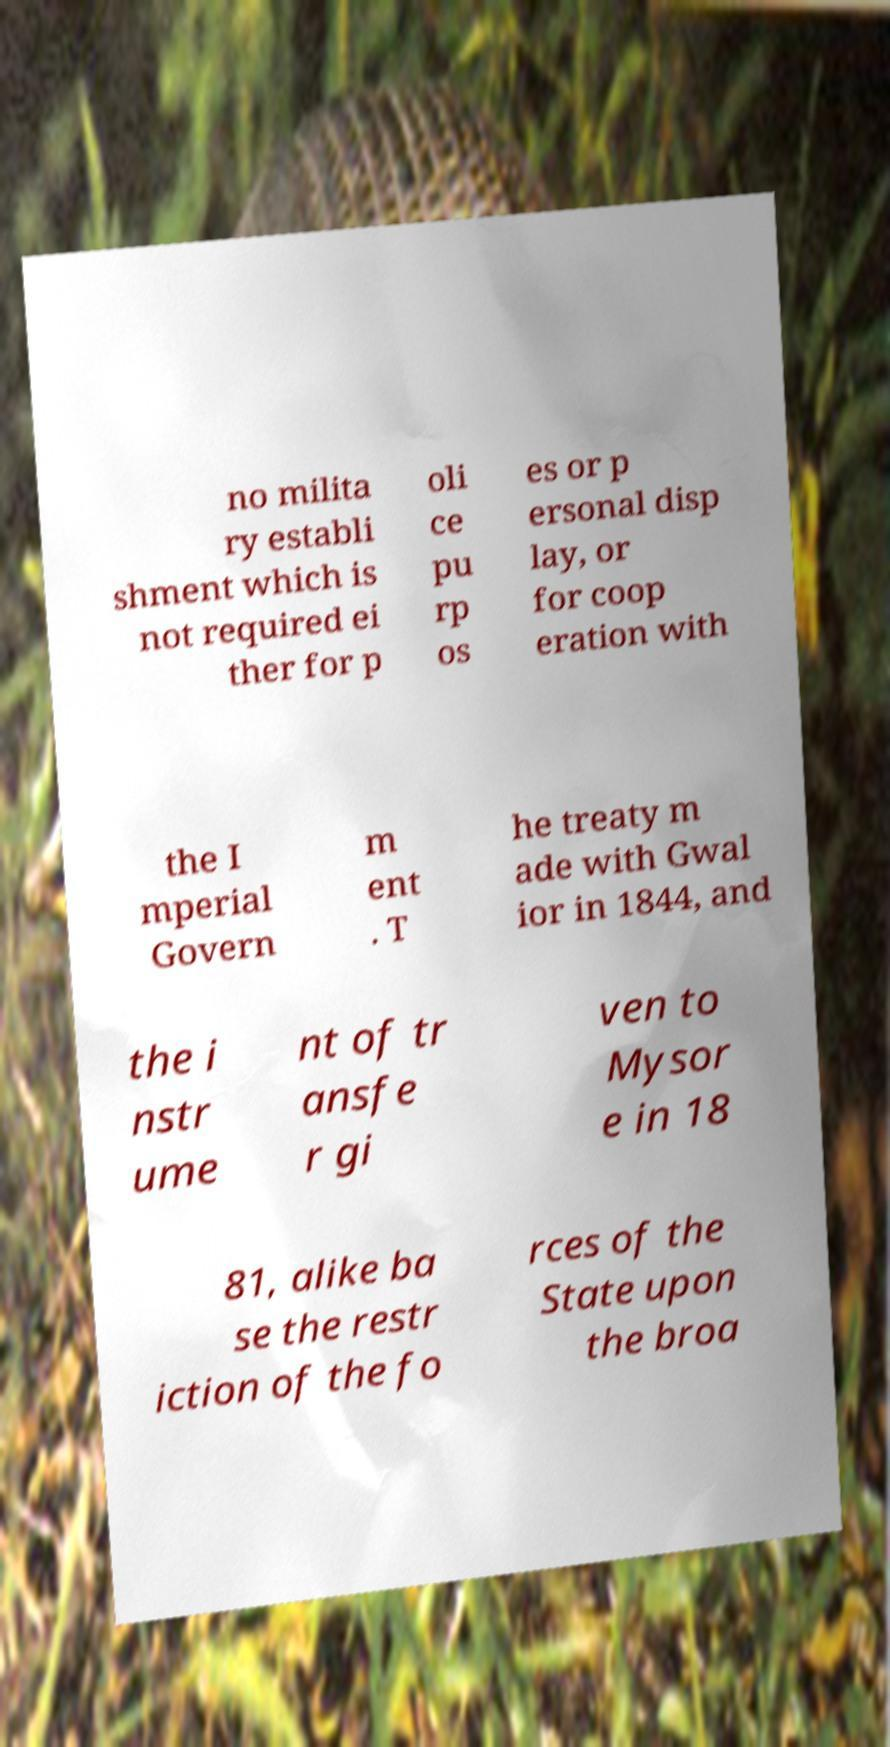For documentation purposes, I need the text within this image transcribed. Could you provide that? no milita ry establi shment which is not required ei ther for p oli ce pu rp os es or p ersonal disp lay, or for coop eration with the I mperial Govern m ent . T he treaty m ade with Gwal ior in 1844, and the i nstr ume nt of tr ansfe r gi ven to Mysor e in 18 81, alike ba se the restr iction of the fo rces of the State upon the broa 